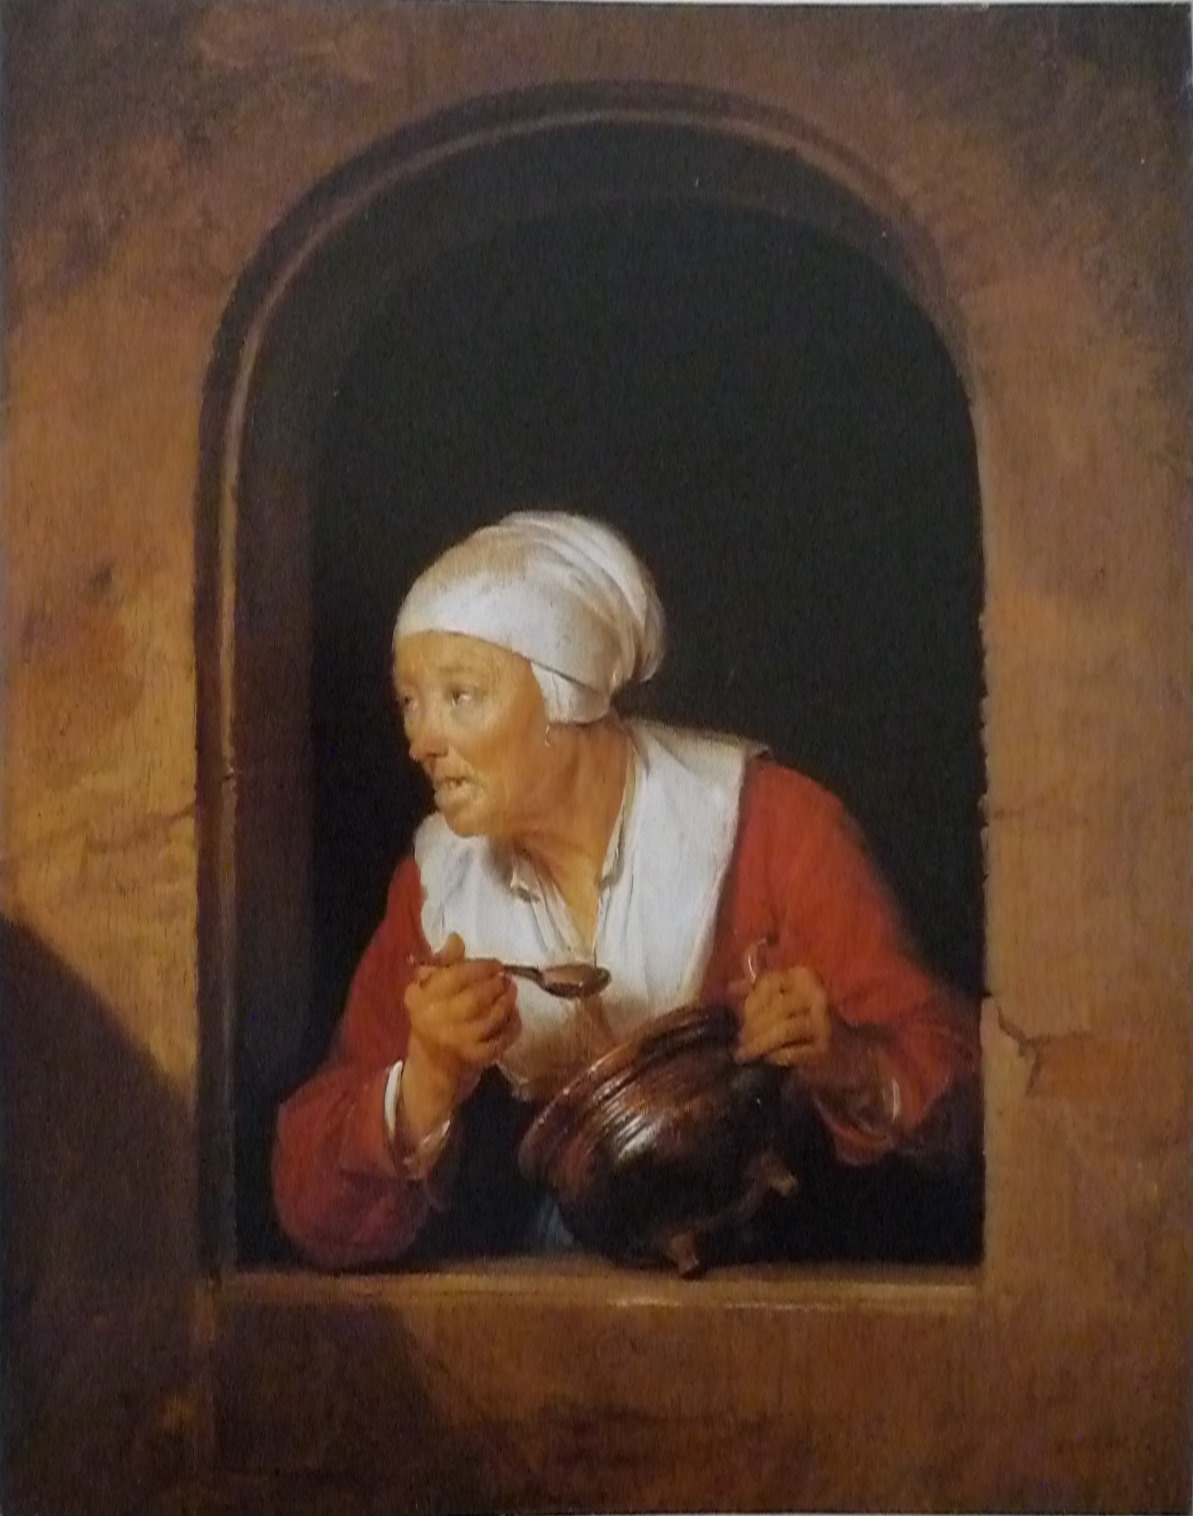Imagine the painting is a scene from a historical drama. Write the next scene. As the elderly woman peers out of her window, trying to discern the source of the noise, the camera pans to a bustling courtyard below. A young messenger, out of breath, bursts through the crowd, clutching a sealed letter with the royal crest. He races towards the woman's house, urgency in every step. The townsfolk murmur in curiosity and concern. Just as he reaches the stone steps, a figure cloaked in dark robes emerges from the shadows, watching the scene intently, his motives concealed beneath his hood. The woman, now fully aware of the commotion, turns back into her modest kitchen, placing the jug down with trembling hands. She prepares herself for the unknown news that's about to disrupt her peaceful evening, unaware of the sinister plot unravelling in the darkened alleyways of the town. What role does the woman play in this unfolding drama? The woman, once a simple villager, holds a key piece to a much larger puzzle. Decades ago, she was entrusted with a secret map leading to a treasure hidden away by a long-forgotten monarch. Only she and a few others know of its existence. The messenger carries a letter that will thrust her into a world of intrigue and danger, as factions vie for the treasure that could change the fate of the kingdom. The cloaked figure, a member of a covert group seeking the treasure for their own gain, has been watching her, waiting for the right moment to strike. Unbeknownst to both the woman and the townsfolk, the peace of their village hangs in the balance of this ancient secret now resurfacing. 